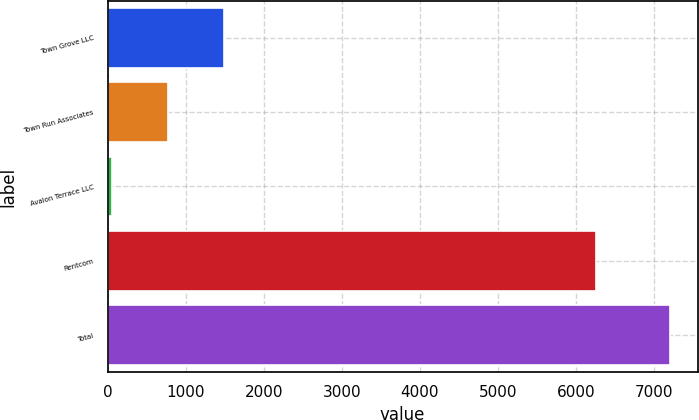Convert chart. <chart><loc_0><loc_0><loc_500><loc_500><bar_chart><fcel>Town Grove LLC<fcel>Town Run Associates<fcel>Avalon Terrace LLC<fcel>Rentcom<fcel>Total<nl><fcel>1486<fcel>772<fcel>58<fcel>6252<fcel>7198<nl></chart> 